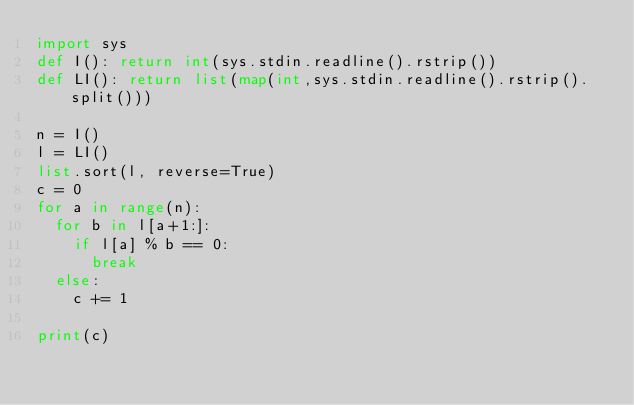Convert code to text. <code><loc_0><loc_0><loc_500><loc_500><_Python_>import sys
def I(): return int(sys.stdin.readline().rstrip())
def LI(): return list(map(int,sys.stdin.readline().rstrip().split()))

n = I()
l = LI()
list.sort(l, reverse=True)
c = 0
for a in range(n):
  for b in l[a+1:]:
    if l[a] % b == 0:
      break
  else:
    c += 1
  
print(c)</code> 